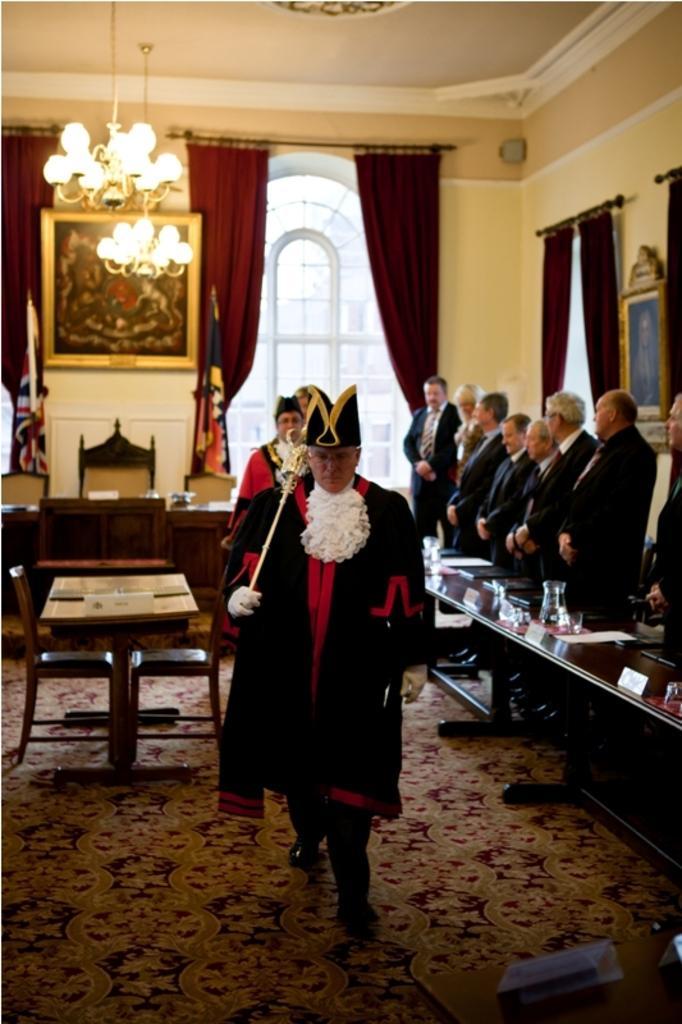Can you describe this image briefly? These persons are standing. We can see tables and chairs on the table we can see glasses,book,jar. This is floor. On the background we can see wall,glass window,curtains. On the top we can see lights. 